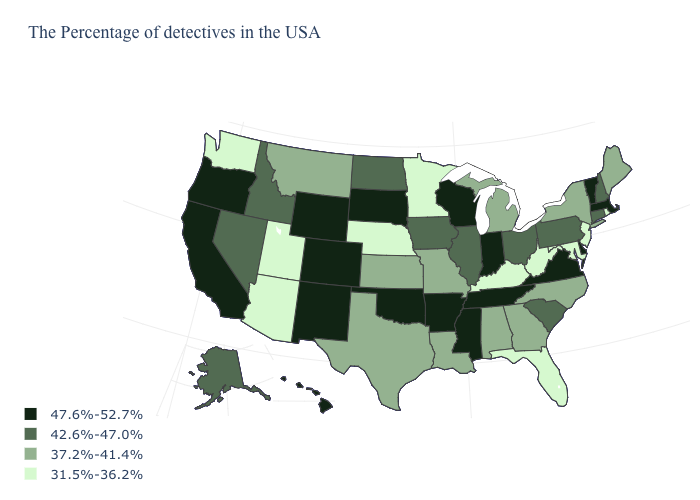Among the states that border Colorado , which have the lowest value?
Be succinct. Nebraska, Utah, Arizona. What is the value of Connecticut?
Short answer required. 42.6%-47.0%. What is the value of Tennessee?
Write a very short answer. 47.6%-52.7%. Which states have the lowest value in the USA?
Concise answer only. Rhode Island, New Jersey, Maryland, West Virginia, Florida, Kentucky, Minnesota, Nebraska, Utah, Arizona, Washington. Name the states that have a value in the range 31.5%-36.2%?
Short answer required. Rhode Island, New Jersey, Maryland, West Virginia, Florida, Kentucky, Minnesota, Nebraska, Utah, Arizona, Washington. Name the states that have a value in the range 37.2%-41.4%?
Give a very brief answer. Maine, New York, North Carolina, Georgia, Michigan, Alabama, Louisiana, Missouri, Kansas, Texas, Montana. What is the value of Ohio?
Give a very brief answer. 42.6%-47.0%. Among the states that border Maryland , does West Virginia have the lowest value?
Give a very brief answer. Yes. Does New Hampshire have a lower value than Virginia?
Write a very short answer. Yes. Name the states that have a value in the range 37.2%-41.4%?
Write a very short answer. Maine, New York, North Carolina, Georgia, Michigan, Alabama, Louisiana, Missouri, Kansas, Texas, Montana. Which states hav the highest value in the Northeast?
Short answer required. Massachusetts, Vermont. Which states have the lowest value in the USA?
Quick response, please. Rhode Island, New Jersey, Maryland, West Virginia, Florida, Kentucky, Minnesota, Nebraska, Utah, Arizona, Washington. Which states have the lowest value in the MidWest?
Give a very brief answer. Minnesota, Nebraska. What is the value of Wyoming?
Short answer required. 47.6%-52.7%. Does the map have missing data?
Short answer required. No. 